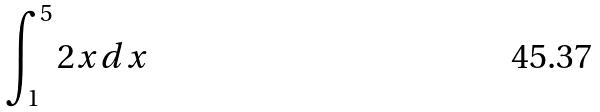Convert formula to latex. <formula><loc_0><loc_0><loc_500><loc_500>\int _ { 1 } ^ { 5 } 2 x d x</formula> 